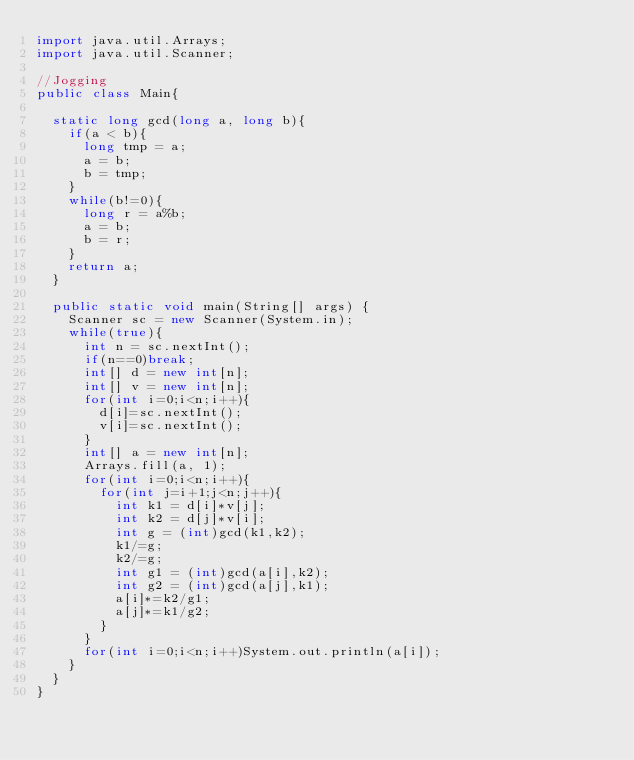Convert code to text. <code><loc_0><loc_0><loc_500><loc_500><_Java_>import java.util.Arrays;
import java.util.Scanner;

//Jogging
public class Main{

	static long gcd(long a, long b){
		if(a < b){
			long tmp = a;
			a = b;
			b = tmp;
		}
		while(b!=0){
			long r = a%b;
			a = b;
			b = r;
		}
		return a;
	}
	
	public static void main(String[] args) {
		Scanner sc = new Scanner(System.in);
		while(true){
			int n = sc.nextInt();
			if(n==0)break;
			int[] d = new int[n];
			int[] v = new int[n];
			for(int i=0;i<n;i++){
				d[i]=sc.nextInt();
				v[i]=sc.nextInt();
			}
			int[] a = new int[n];
			Arrays.fill(a, 1);
			for(int i=0;i<n;i++){
				for(int j=i+1;j<n;j++){
					int k1 = d[i]*v[j];
					int k2 = d[j]*v[i];
					int g = (int)gcd(k1,k2);
					k1/=g;
					k2/=g;
					int g1 = (int)gcd(a[i],k2);
					int g2 = (int)gcd(a[j],k1);
					a[i]*=k2/g1;
					a[j]*=k1/g2;
				}
			}
			for(int i=0;i<n;i++)System.out.println(a[i]);
		}
	}
}</code> 